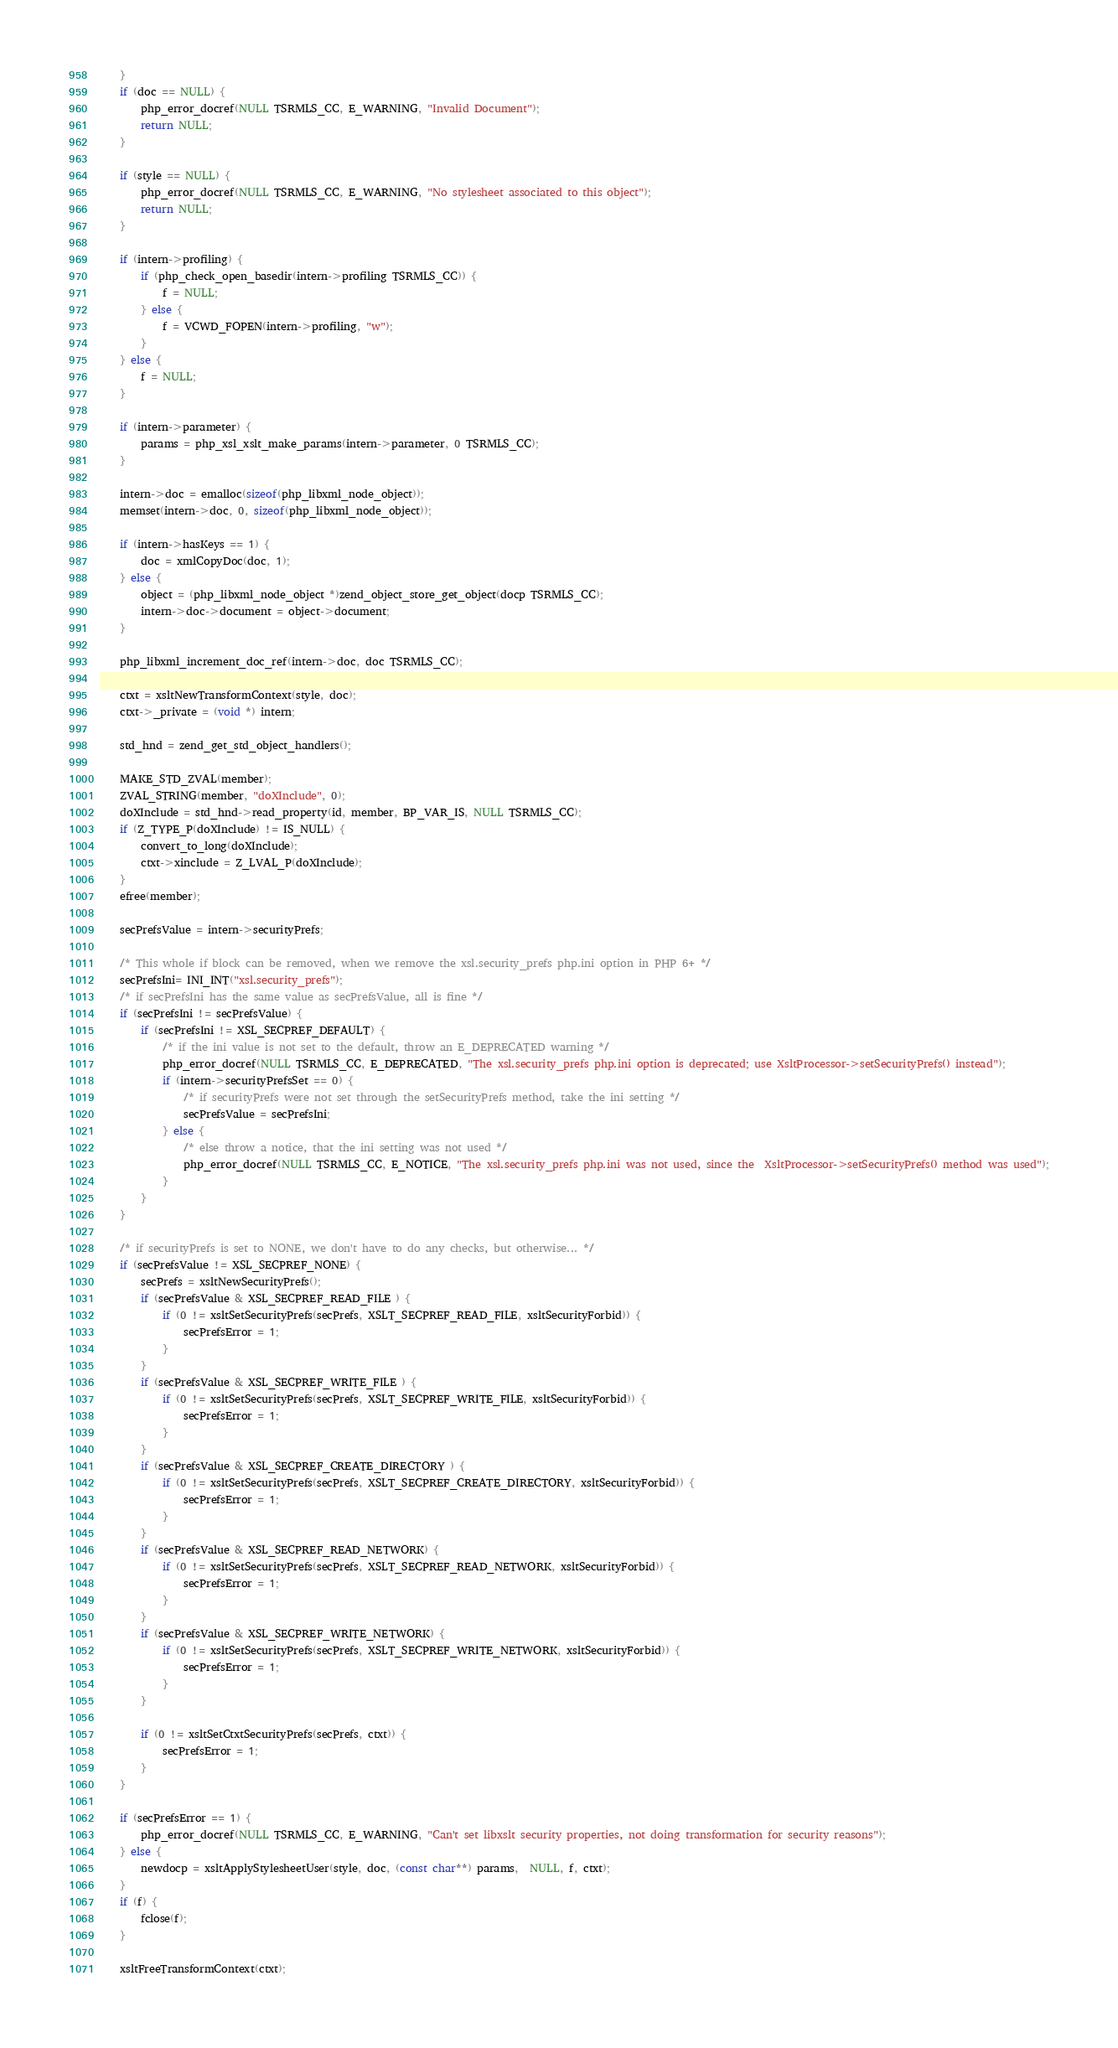<code> <loc_0><loc_0><loc_500><loc_500><_C_>	}
	if (doc == NULL) {
		php_error_docref(NULL TSRMLS_CC, E_WARNING, "Invalid Document");
		return NULL;
	}

	if (style == NULL) {
		php_error_docref(NULL TSRMLS_CC, E_WARNING, "No stylesheet associated to this object");
		return NULL;
	}
	
	if (intern->profiling) {
		if (php_check_open_basedir(intern->profiling TSRMLS_CC)) {
			f = NULL;
		} else {
			f = VCWD_FOPEN(intern->profiling, "w");
		}
	} else {
		f = NULL;
	}
	
	if (intern->parameter) {
		params = php_xsl_xslt_make_params(intern->parameter, 0 TSRMLS_CC);
	}

	intern->doc = emalloc(sizeof(php_libxml_node_object));
	memset(intern->doc, 0, sizeof(php_libxml_node_object));

	if (intern->hasKeys == 1) {
		doc = xmlCopyDoc(doc, 1);
	} else {
		object = (php_libxml_node_object *)zend_object_store_get_object(docp TSRMLS_CC);
		intern->doc->document = object->document;
	}

	php_libxml_increment_doc_ref(intern->doc, doc TSRMLS_CC);

	ctxt = xsltNewTransformContext(style, doc);
	ctxt->_private = (void *) intern;

	std_hnd = zend_get_std_object_handlers();

	MAKE_STD_ZVAL(member);
	ZVAL_STRING(member, "doXInclude", 0);
	doXInclude = std_hnd->read_property(id, member, BP_VAR_IS, NULL TSRMLS_CC);
	if (Z_TYPE_P(doXInclude) != IS_NULL) {
		convert_to_long(doXInclude);
		ctxt->xinclude = Z_LVAL_P(doXInclude);
	}
	efree(member);

	secPrefsValue = intern->securityPrefs;
	
	/* This whole if block can be removed, when we remove the xsl.security_prefs php.ini option in PHP 6+ */
	secPrefsIni= INI_INT("xsl.security_prefs");
	/* if secPrefsIni has the same value as secPrefsValue, all is fine */
	if (secPrefsIni != secPrefsValue) {
		if (secPrefsIni != XSL_SECPREF_DEFAULT) {
			/* if the ini value is not set to the default, throw an E_DEPRECATED warning */
			php_error_docref(NULL TSRMLS_CC, E_DEPRECATED, "The xsl.security_prefs php.ini option is deprecated; use XsltProcessor->setSecurityPrefs() instead");
			if (intern->securityPrefsSet == 0) {
				/* if securityPrefs were not set through the setSecurityPrefs method, take the ini setting */
				secPrefsValue = secPrefsIni;
			} else {
				/* else throw a notice, that the ini setting was not used */
				php_error_docref(NULL TSRMLS_CC, E_NOTICE, "The xsl.security_prefs php.ini was not used, since the  XsltProcessor->setSecurityPrefs() method was used");
			}
		}
	}

	/* if securityPrefs is set to NONE, we don't have to do any checks, but otherwise... */
	if (secPrefsValue != XSL_SECPREF_NONE) {
		secPrefs = xsltNewSecurityPrefs(); 
		if (secPrefsValue & XSL_SECPREF_READ_FILE ) { 
			if (0 != xsltSetSecurityPrefs(secPrefs, XSLT_SECPREF_READ_FILE, xsltSecurityForbid)) { 
				secPrefsError = 1;
			}
		}
		if (secPrefsValue & XSL_SECPREF_WRITE_FILE ) { 
			if (0 != xsltSetSecurityPrefs(secPrefs, XSLT_SECPREF_WRITE_FILE, xsltSecurityForbid)) { 
				secPrefsError = 1;
			}
		}
		if (secPrefsValue & XSL_SECPREF_CREATE_DIRECTORY ) { 
			if (0 != xsltSetSecurityPrefs(secPrefs, XSLT_SECPREF_CREATE_DIRECTORY, xsltSecurityForbid)) { 
				secPrefsError = 1;
			}
		}
		if (secPrefsValue & XSL_SECPREF_READ_NETWORK) { 
			if (0 != xsltSetSecurityPrefs(secPrefs, XSLT_SECPREF_READ_NETWORK, xsltSecurityForbid)) { 
				secPrefsError = 1;
			}
		}
		if (secPrefsValue & XSL_SECPREF_WRITE_NETWORK) { 
			if (0 != xsltSetSecurityPrefs(secPrefs, XSLT_SECPREF_WRITE_NETWORK, xsltSecurityForbid)) { 
				secPrefsError = 1;
			}
		}
	
		if (0 != xsltSetCtxtSecurityPrefs(secPrefs, ctxt)) { 
			secPrefsError = 1;
		}
	}
	
	if (secPrefsError == 1) {
		php_error_docref(NULL TSRMLS_CC, E_WARNING, "Can't set libxslt security properties, not doing transformation for security reasons");
	} else {
		newdocp = xsltApplyStylesheetUser(style, doc, (const char**) params,  NULL, f, ctxt);
	}
	if (f) {
		fclose(f);
	}
	
	xsltFreeTransformContext(ctxt);</code> 